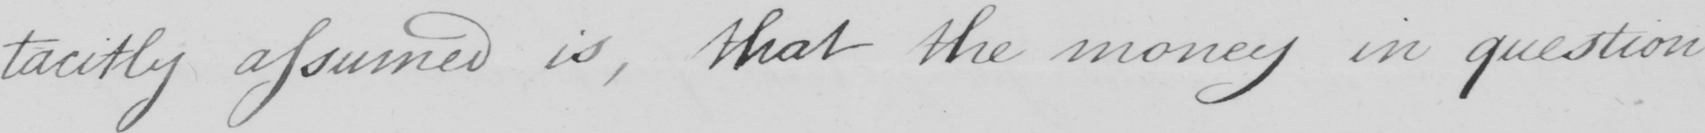Please transcribe the handwritten text in this image. tacitly assumed is , that the money in question 